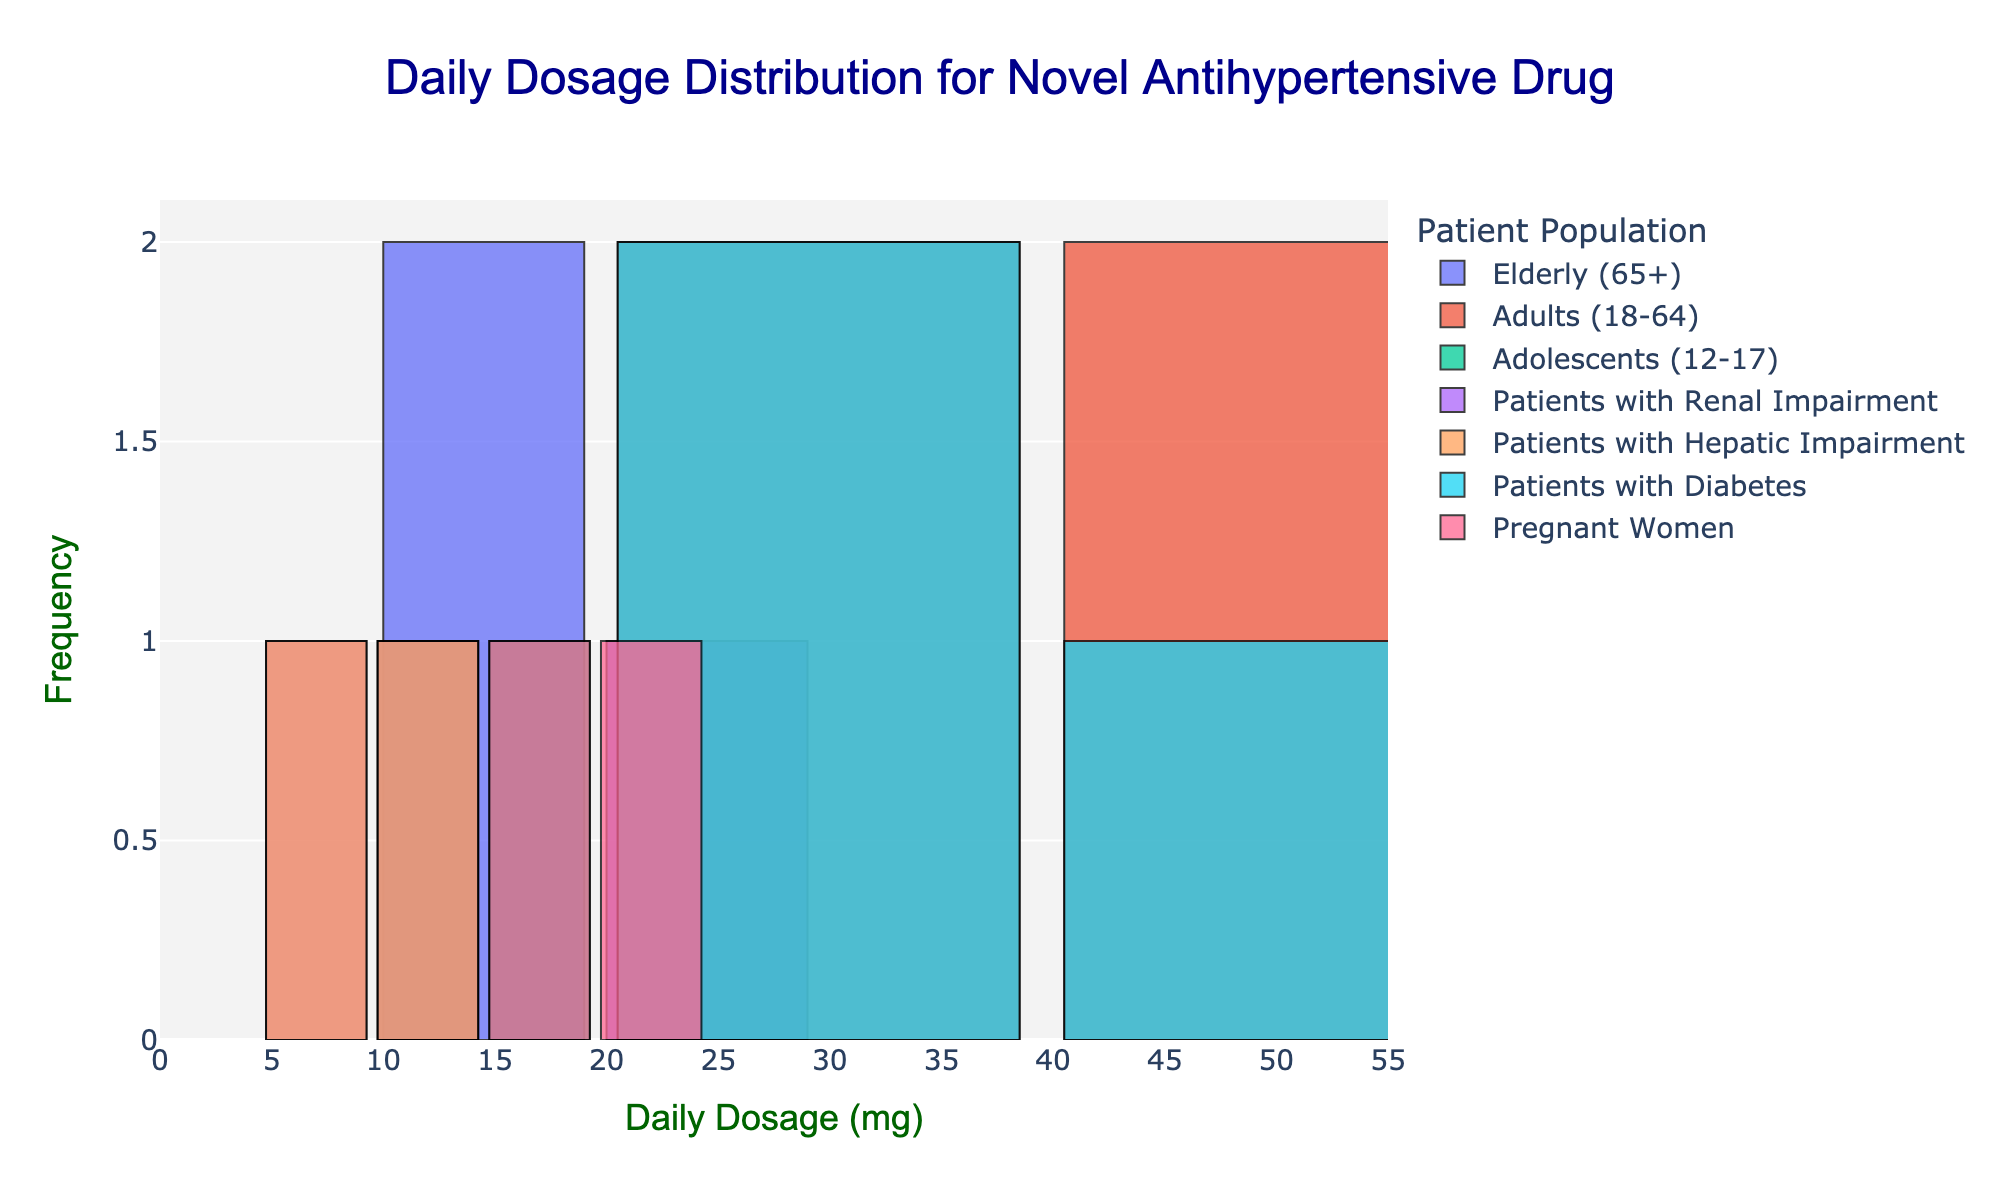What is the title of the histogram? The title is usually displayed at the top center of the figure. You can see that it reads "Daily Dosage Distribution for Novel Antihypertensive Drug".
Answer: Daily Dosage Distribution for Novel Antihypertensive Drug Which patient population has a dosage range that includes 50 mg? Looking at the different bars and their labelled ranges, the "Adults (18-64)" population has a bar at the 50 mg mark.
Answer: Adults (18-64) How many distinct patient populations are represented in the histogram? The legend on the right side of the figure lists all the patient populations, which can be counted to find the total number. The distinct populations are Elderly (65+), Adults (18-64), Adolescents (12-17), Patients with Renal Impairment, Patients with Hepatic Impairment, Patients with Diabetes, and Pregnant Women.
Answer: 7 Which dosage range has the highest frequency for the "Elderly (65+)" population? By looking at the bars corresponding to the "Elderly (65+)" and comparing their height, the bar at the 20 mg mark is the tallest, indicating the highest frequency.
Answer: 20 mg What is the dosage range for "Patients with Renal Impairment"? The bars corresponding to "Patients with Renal Impairment" are located at the 5 mg and 10 mg marks.
Answer: 5 mg and 10 mg Which patient population has the widest range of dosages? Comparing the ranges of dosage values for each population by scanning across the bars, the "Adults (18-64)" population spans from 20 mg to 50 mg, indicating the widest range.
Answer: Adults (18-64) How does the dosage distribution for "Pregnant Women" compare with "Adolescents (12-17)"? By comparing the locations of the bars for both populations: "Pregnant Women" have bars at 15 mg and 20 mg, while "Adolescents (12-17)" have bars at 10 mg and 15 mg. Both have some overlap at 15 mg but differ in other ranges.
Answer: Both have a bar at 15 mg, Pregnant Women have an additional bar at 20 mg, whereas Adolescents have one additional bar at 10 mg What is the most common dosage for "Patients with Diabetes"? By identifying the tallest bar corresponding to "Patients with Diabetes", the most common dosage is at both 20 mg and 30 mg since they both have the same height.
Answer: 20 mg and 30 mg Which population does not have any dosage above 10 mg? By scanning the figure, the populations "Patients with Renal Impairment" and "Patients with Hepatic Impairment" have bars only at the 5 mg and 10 mg marks, indicating no dosages above 10 mg.
Answer: Patients with Renal Impairment and Patients with Hepatic Impairment 